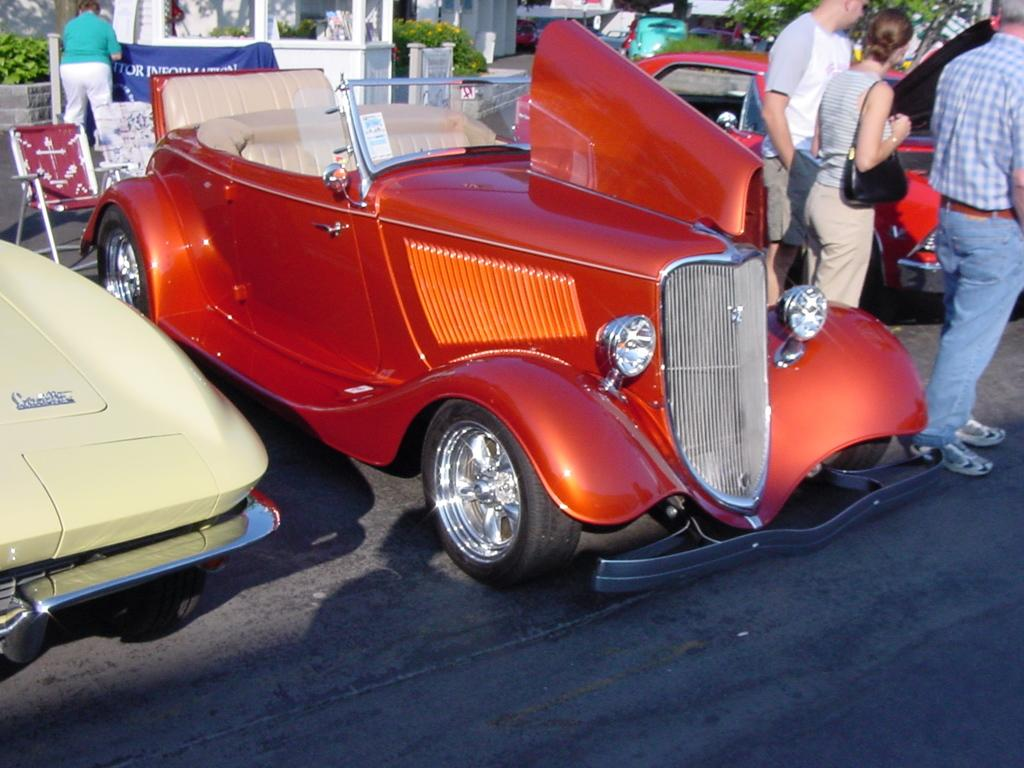What types of objects are in the image? There are vehicles and people in the image. What is at the bottom of the image? There is a road at the bottom of the image. What can be seen in the background of the image? Chairs, banners, plants, pillars, and other objects are visible in the background of the image. How many hydrants are visible in the image? There are no hydrants present in the image. What rule is being enforced by the people in the image? There is no rule being enforced by the people in the image; we cannot determine their actions or intentions from the image alone. --- Facts: 1. There is a person holding a book in the image. 2. The person is sitting on a chair. 3. There is a table in front of the person. 4. The table has a lamp on it. 5. The background of the image is a room. Absurd Topics: parrot, ocean, bicycle Conversation: What is the person in the image holding? The person is holding a book in the image. What is the person sitting on? The person is sitting on a chair. What is in front of the person? There is a table in front of the person. What is on the table? The table has a lamp on it. What can be seen in the background of the image? The background of the image is a room. Reasoning: Let's think step by step in order to produce the conversation. We start by identifying the main subject in the image, which is the person holding a book. Then, we describe the person's position and the objects around them, such as the chair, table, and lamp. Finally, we mention the background of the image, which is a room. Each question is designed to elicit a specific detail about the image that is known from the provided facts. Absurd Question/Answer: Can you see a parrot flying over the ocean in the image? There is no parrot or ocean present in the image; it is a person sitting in a room with a book, chair, table, and lamp. 